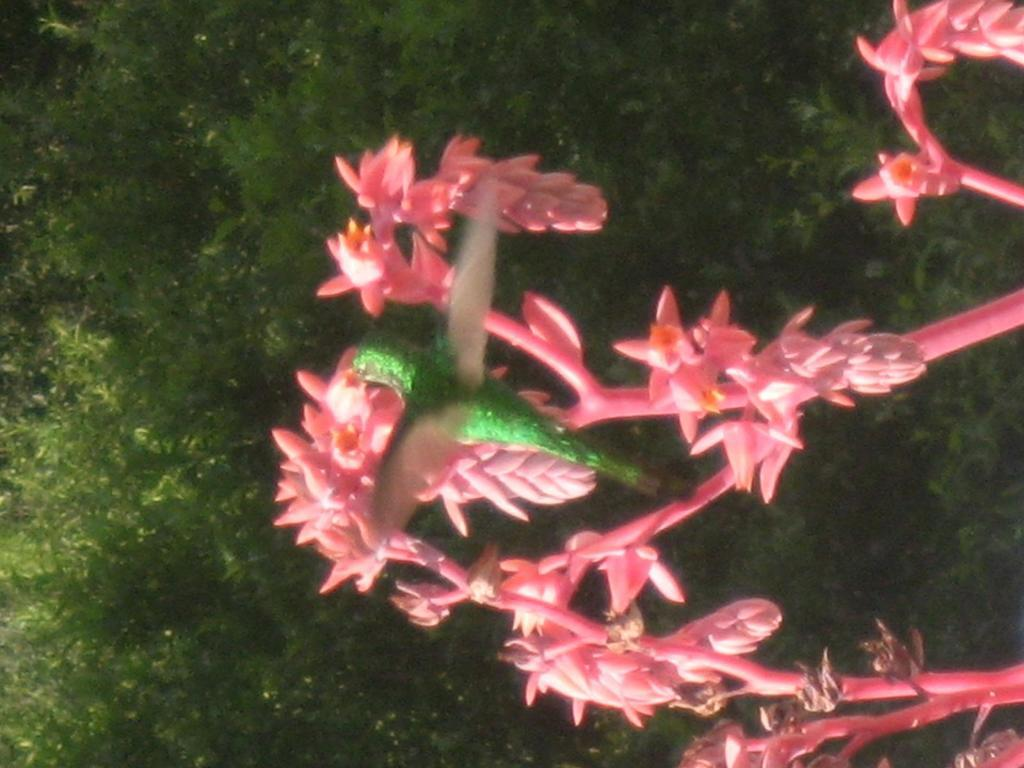What animal can be seen in the picture? There is a bird in the picture. What is the bird doing in the picture? The bird is playing on the flowers. What can be seen in the background of the picture? There are trees visible in the background of the picture. What type of chin can be seen on the bird in the image? There is no chin visible on the bird in the image, as birds do not have chins. 